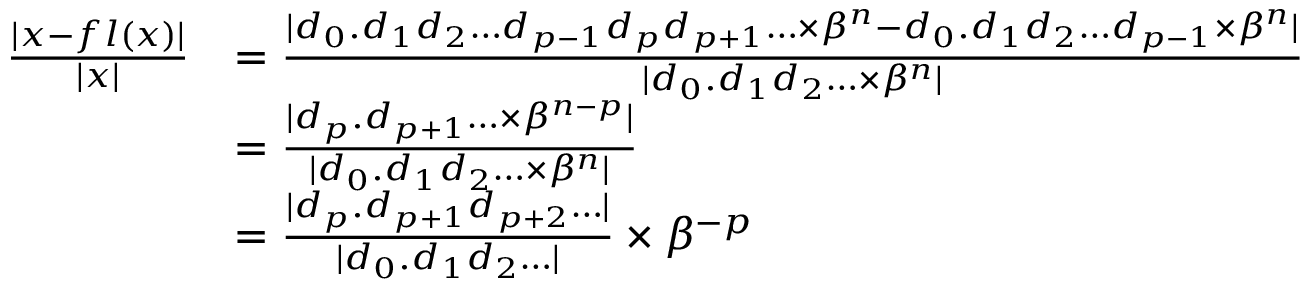Convert formula to latex. <formula><loc_0><loc_0><loc_500><loc_500>{ \begin{array} { r l } { { \frac { | x - f l ( x ) | } { | x | } } } & { = { \frac { | d _ { 0 } . d _ { 1 } d _ { 2 } \dots d _ { p - 1 } d _ { p } d _ { p + 1 } \dots \times \beta ^ { n } - d _ { 0 } . d _ { 1 } d _ { 2 } \dots d _ { p - 1 } \times \beta ^ { n } | } { | d _ { 0 } . d _ { 1 } d _ { 2 } \dots \times \beta ^ { n } | } } } \\ & { = { \frac { | d _ { p } . d _ { p + 1 } \dots \times \beta ^ { n - p } | } { | d _ { 0 } . d _ { 1 } d _ { 2 } \dots \times \beta ^ { n } | } } } \\ & { = { \frac { | d _ { p } . d _ { p + 1 } d _ { p + 2 } \dots | } { | d _ { 0 } . d _ { 1 } d _ { 2 } \dots | } } \times \beta ^ { - p } } \end{array} }</formula> 